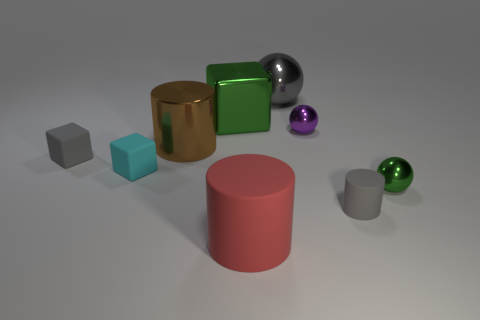What number of other objects are there of the same shape as the purple object?
Your response must be concise. 2. What size is the gray matte thing left of the gray matte thing that is on the right side of the green shiny thing that is left of the small purple sphere?
Keep it short and to the point. Small. What number of yellow things are either tiny cylinders or tiny shiny spheres?
Provide a short and direct response. 0. What is the shape of the gray matte thing to the left of the big cube that is in front of the large gray object?
Your answer should be very brief. Cube. There is a shiny object that is on the right side of the tiny matte cylinder; is its size the same as the green thing that is on the left side of the red cylinder?
Keep it short and to the point. No. Is there a brown object made of the same material as the cyan thing?
Your answer should be very brief. No. The ball that is the same color as the tiny cylinder is what size?
Make the answer very short. Large. There is a green metallic object right of the small metal object that is behind the cyan rubber object; is there a large green object that is to the right of it?
Your answer should be compact. No. Are there any tiny gray rubber objects to the left of the purple thing?
Provide a short and direct response. Yes. There is a tiny thing that is right of the small cylinder; what number of large metal balls are on the right side of it?
Your answer should be compact. 0. 